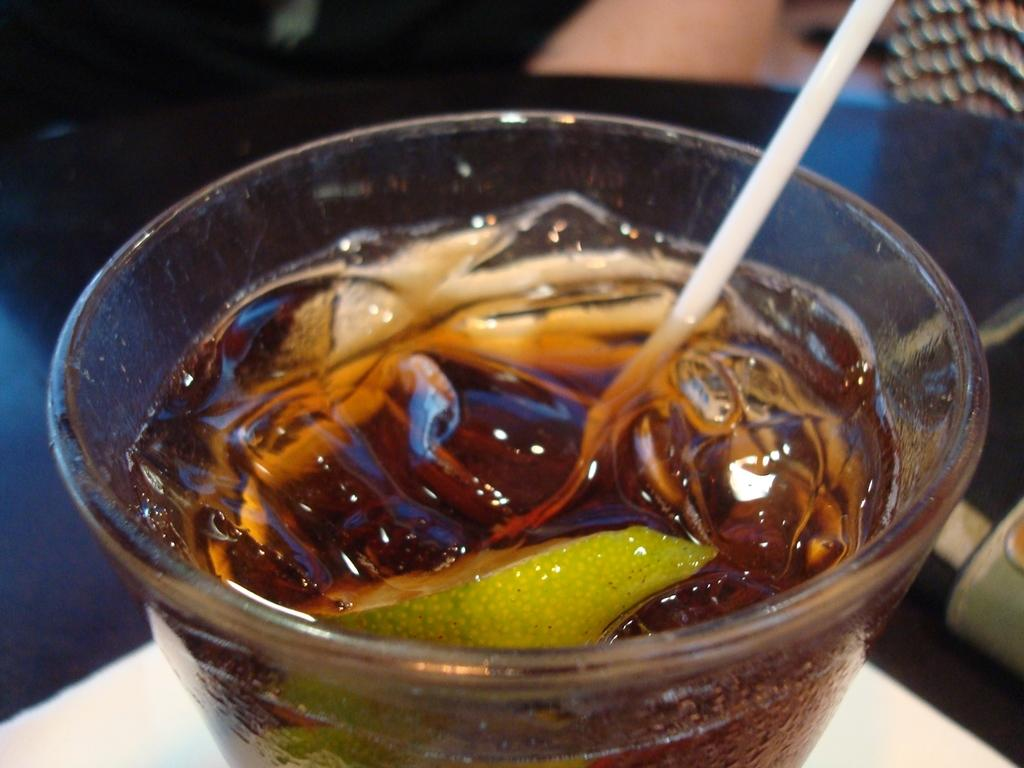What is in the bowl that is visible in the image? There is a food item in the bowl that is visible in the image. What utensil is present in the image? There is a spoon in the image. What is the color of the surface on which the bowl is placed? The bowl is on a white surface. What is the existence of plastic like in the society depicted in the image? There is no information about the existence of plastic or society in the image, as it only features a bowl with a food item and a spoon on a white surface. 